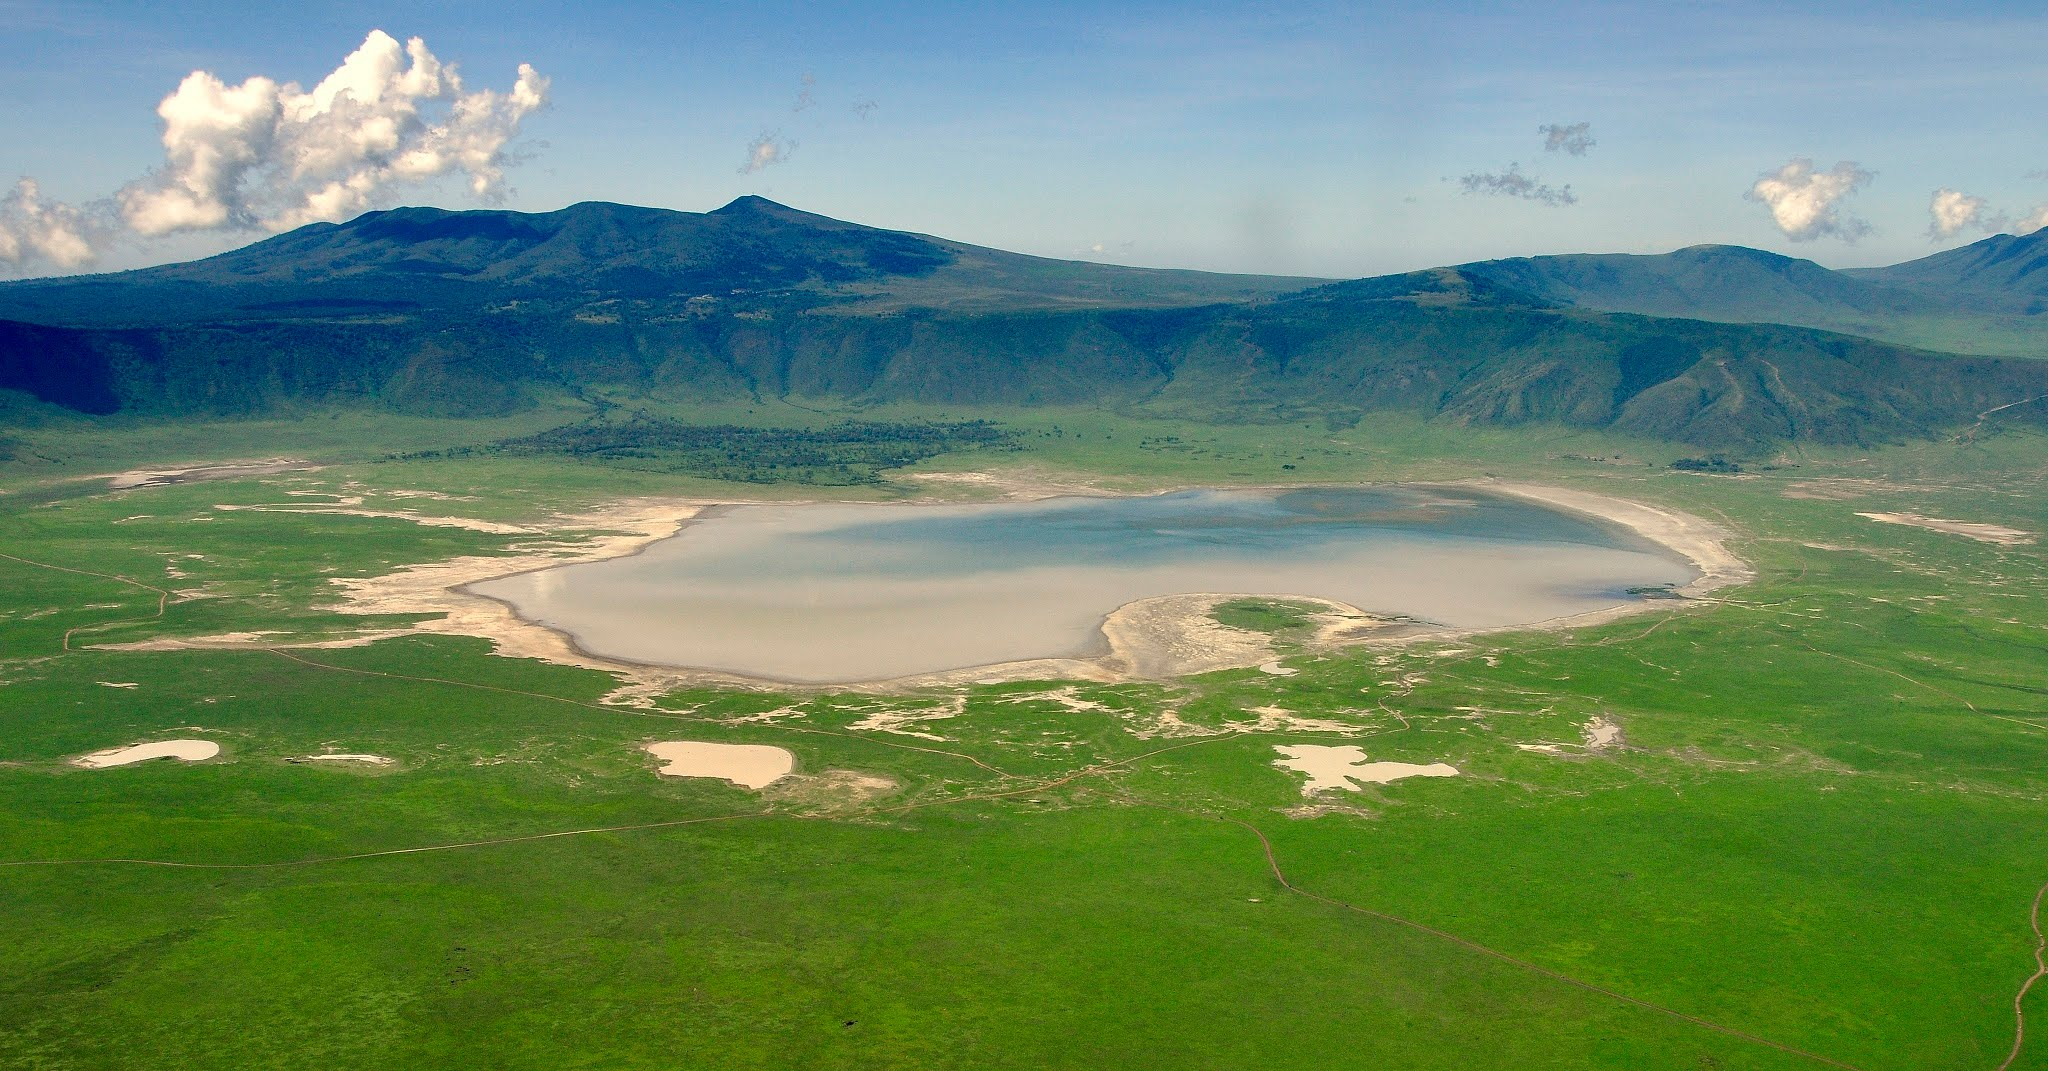How does the crater's unique geography affect the ecosystem within it? Ngorongoro Crater's unique geological formation has created a self-contained ecosystem with distinct characteristics. The high walls of the caldera serve as natural barriers to the animal population, keeping the movement of species in and out restricted. This isolation has encouraged a mini ecological system where almost all the species necessary for the survival of an African game reserve are present. The varying altitude and habitats ranging from the forest-lined rim to grasslands, wetlands, and the alkaline lake design a wide array of microenvironments that support specific plant and animal life. Furthermore, the relatively small area intensifies predator-prey interactions, and the permanent availability of water and forage supports wildlife during dry periods. Thus, while the geography limits the animals' range, it also fosters a thriving, diverse community. 